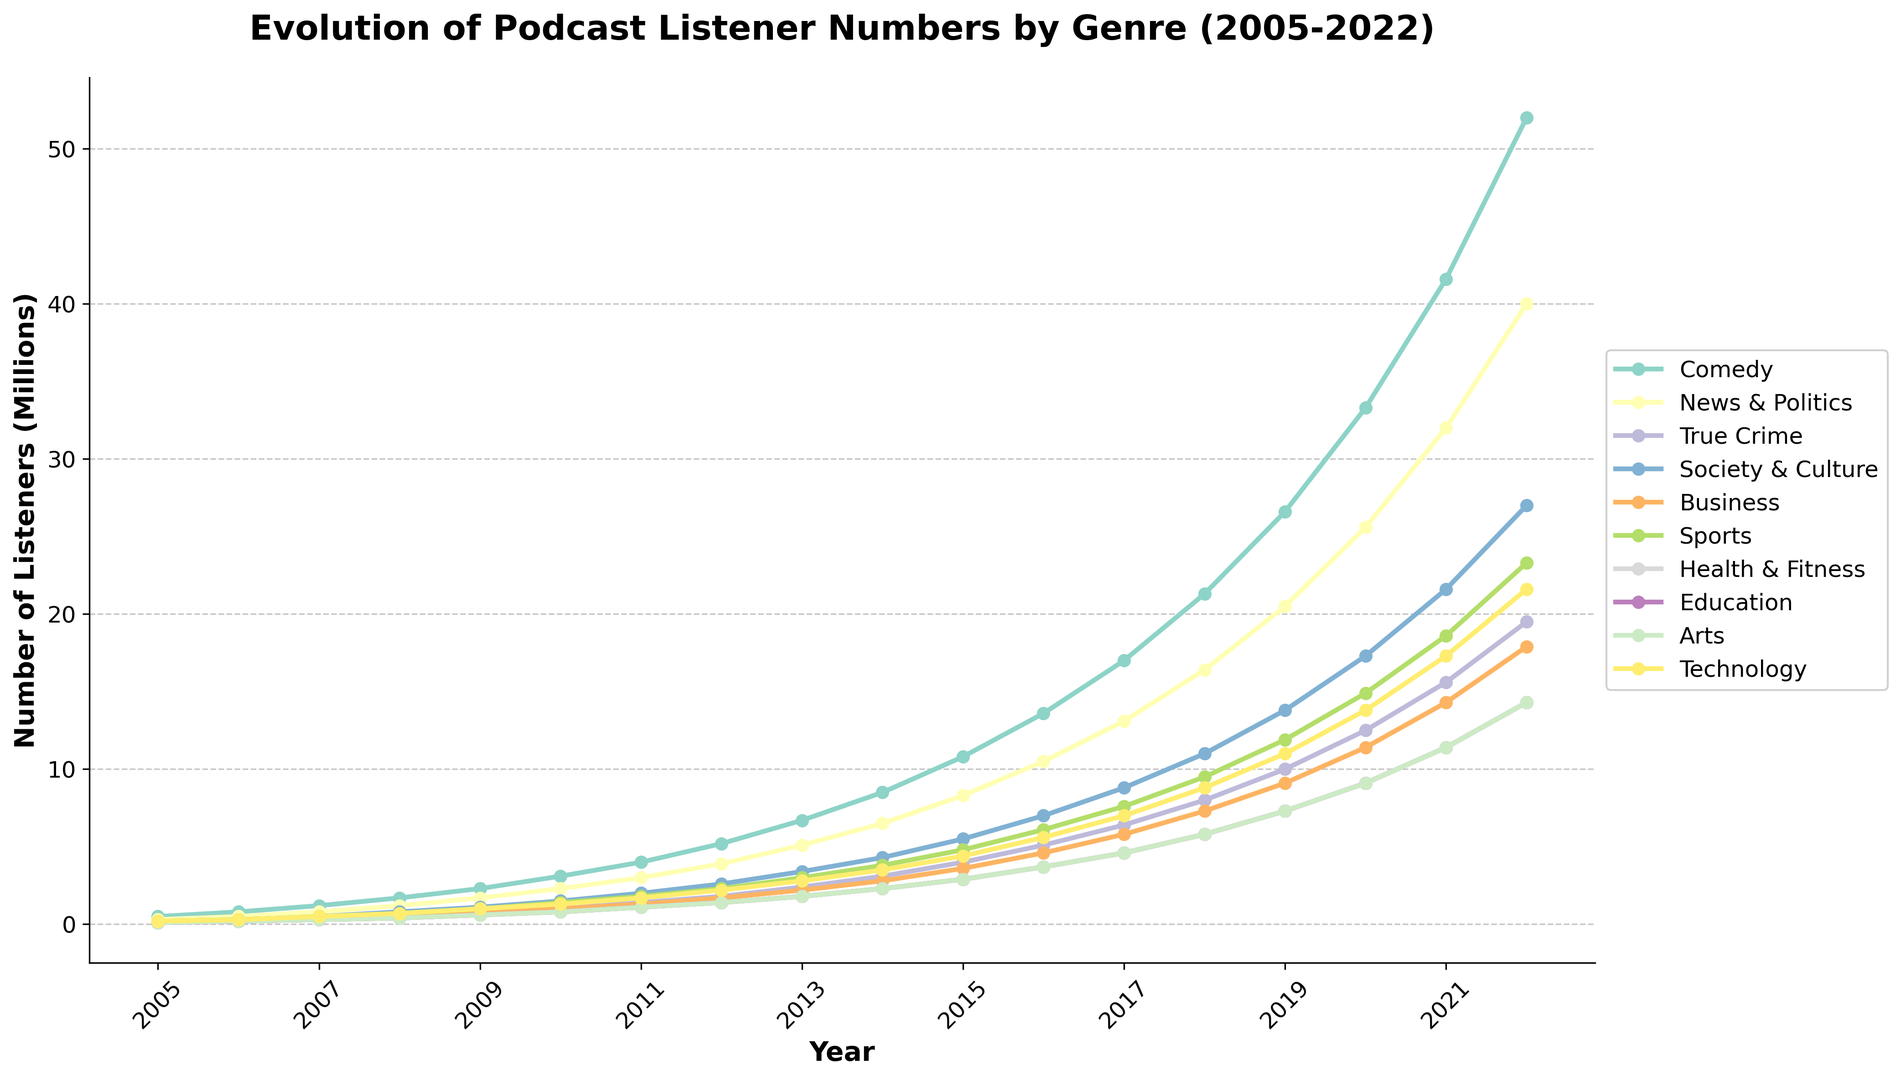What genre had the highest number of listeners in 2022? By looking at the rightmost end of each line in the chart, the genre with the highest point on the y-axis in 2022 represents the highest number of listeners. This genre is Comedy.
Answer: Comedy Which genre had the slowest growth in listeners between 2005 and 2022? To determine the genre with the slowest growth, examine the difference in listeners from 2005 to 2022 for each genre. The genre with the smallest difference is Health & Fitness.
Answer: Health & Fitness How did the listener numbers for True Crime compare to Business in 2015? Look at the data points for True Crime and Business in 2015. True Crime has about 4 million listeners, whereas Business has about 3.6 million listeners. Therefore, True Crime has more listeners than Business in 2015.
Answer: True Crime has more listeners What was the average number of listeners for Technology from 2005 to 2010? Sum the number of listeners for Technology from 2005 to 2010 and divide by the number of years. (0.2 + 0.3 + 0.5 + 0.7 + 1.0 + 1.3) / 6 = 1.67/6 ≈ 0.28 million.
Answer: 0.28 million Which year saw the largest increase in Comedy listeners? Compare the year-over-year increase for Comedy listeners. The biggest increase occurred between 2018 and 2019, with an increase from 21.3 million to 26.6 million (5.3 million increase).
Answer: 2019 Which genre showed a consistent increase in listeners every year from 2005 to 2022? Verify if, for any genre, each year has a higher number of listeners than the previous year. Comedy consistently shows an increase each year.
Answer: Comedy What is the difference in the number of listeners between Society & Culture and Health & Fitness in 2020? In 2020, Society & Culture had 17.3 million listeners, and Health & Fitness had 9.1 million listeners. The difference is 17.3 - 9.1 = 8.2 million.
Answer: 8.2 million By how much did News & Politics listeners increase from 2011 to 2018? News & Politics listeners were 3 million in 2011 and 16.4 million in 2018. The increase is 16.4 - 3 = 13.4 million.
Answer: 13.4 million What percentage of the total listener increase from 2012 to 2022 does True Crime contribute? From 2012 to 2022, True Crime listeners increased by 19.5 - 1.8 = 17.7 million. First, calculate the total increase for all genres from 2012 to 2022, then find the percentage. Total listener increase from 2012 to 2022 is 245.4 - 41.9 = 203.5 million. So, the percentage is (17.7 / 203.5) * 100% ≈ 8.7%.
Answer: 8.7% Which genre witnessed the highest absolute growth from 2005 to 2022? Compare the difference in listener numbers from 2005 to 2022 for each genre. Comedy increased from 0.5 million to 52 million, which is the highest absolute growth of 51.5 million.
Answer: Comedy 